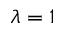Convert formula to latex. <formula><loc_0><loc_0><loc_500><loc_500>\lambda = 1</formula> 